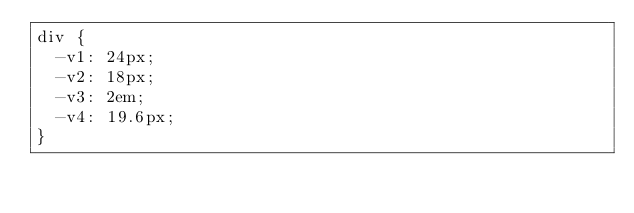Convert code to text. <code><loc_0><loc_0><loc_500><loc_500><_CSS_>div {
  -v1: 24px;
  -v2: 18px;
  -v3: 2em;
  -v4: 19.6px;
}
</code> 